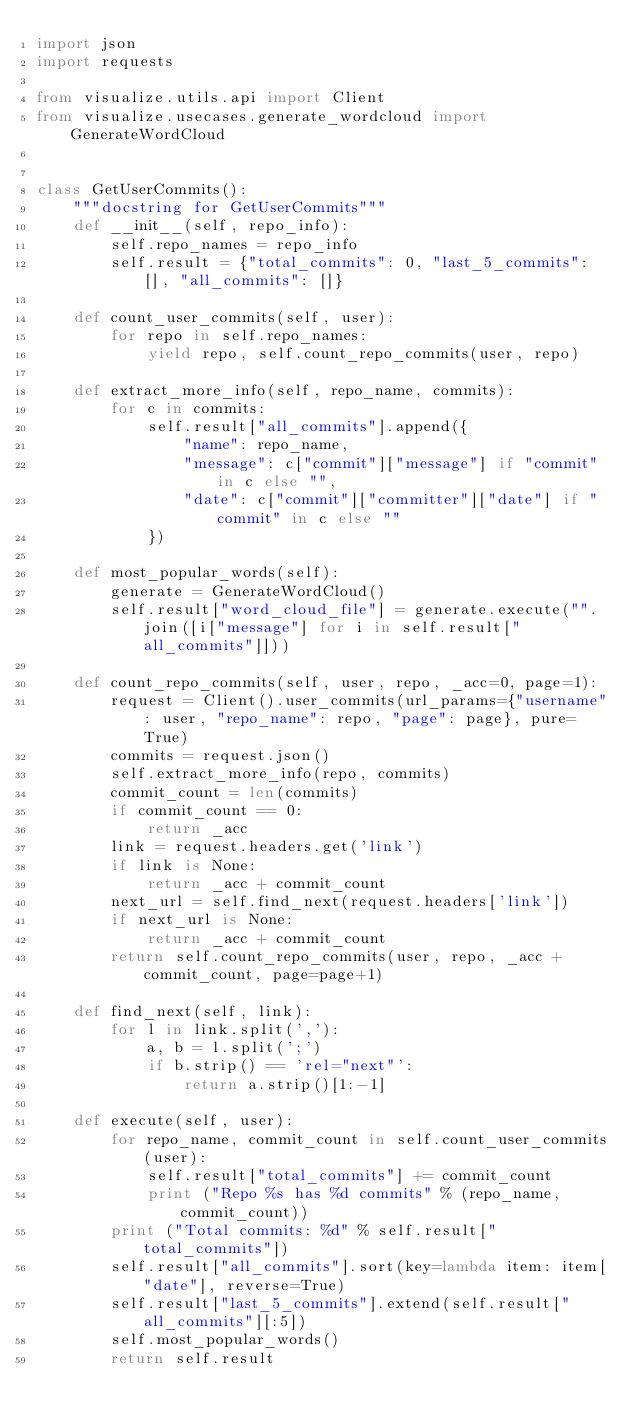Convert code to text. <code><loc_0><loc_0><loc_500><loc_500><_Python_>import json
import requests

from visualize.utils.api import Client
from visualize.usecases.generate_wordcloud import GenerateWordCloud


class GetUserCommits():
	"""docstring for GetUserCommits"""
	def __init__(self, repo_info):
		self.repo_names = repo_info
		self.result = {"total_commits": 0, "last_5_commits": [], "all_commits": []}

	def count_user_commits(self, user):
		for repo in self.repo_names:
			yield repo, self.count_repo_commits(user, repo)

	def extract_more_info(self, repo_name, commits):
		for c in commits:
			self.result["all_commits"].append({
				"name": repo_name,
				"message": c["commit"]["message"] if "commit" in c else "",
				"date": c["commit"]["committer"]["date"] if "commit" in c else ""
			})

	def most_popular_words(self):
		generate = GenerateWordCloud()
		self.result["word_cloud_file"] = generate.execute("".join([i["message"] for i in self.result["all_commits"]]))

	def count_repo_commits(self, user, repo, _acc=0, page=1):
		request = Client().user_commits(url_params={"username": user, "repo_name": repo, "page": page}, pure=True)
		commits = request.json()
		self.extract_more_info(repo, commits)
		commit_count = len(commits)
		if commit_count == 0:
			return _acc
		link = request.headers.get('link')
		if link is None:
			return _acc + commit_count
		next_url = self.find_next(request.headers['link'])
		if next_url is None:
			return _acc + commit_count
		return self.count_repo_commits(user, repo, _acc + commit_count, page=page+1)

	def find_next(self, link):
		for l in link.split(','):
			a, b = l.split(';')
			if b.strip() == 'rel="next"':
				return a.strip()[1:-1]

	def execute(self, user):
		for repo_name, commit_count in self.count_user_commits(user):
			self.result["total_commits"] += commit_count
			print ("Repo %s has %d commits" % (repo_name, commit_count))
		print ("Total commits: %d" % self.result["total_commits"])
		self.result["all_commits"].sort(key=lambda item: item["date"], reverse=True)
		self.result["last_5_commits"].extend(self.result["all_commits"][:5])
		self.most_popular_words()
		return self.result

</code> 